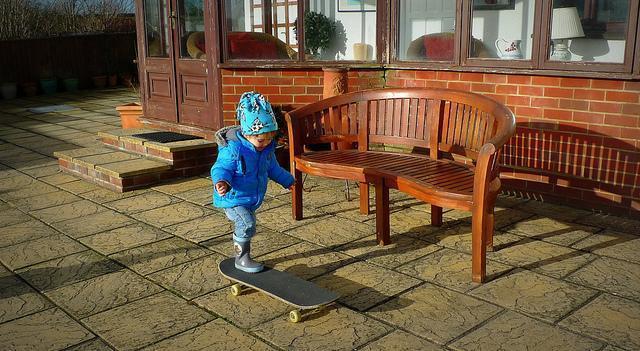How many benches?
Give a very brief answer. 1. How many benches are in the picture?
Give a very brief answer. 1. 